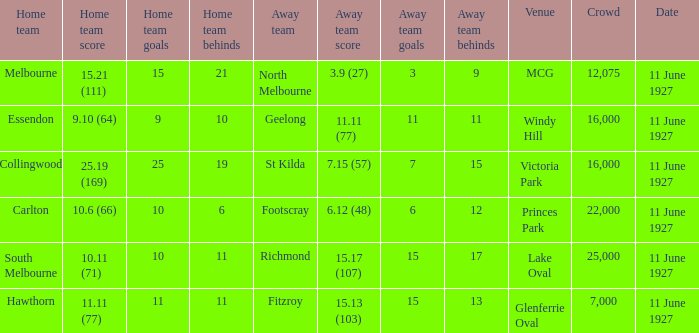Which host team battled against the away team geelong? Essendon. 